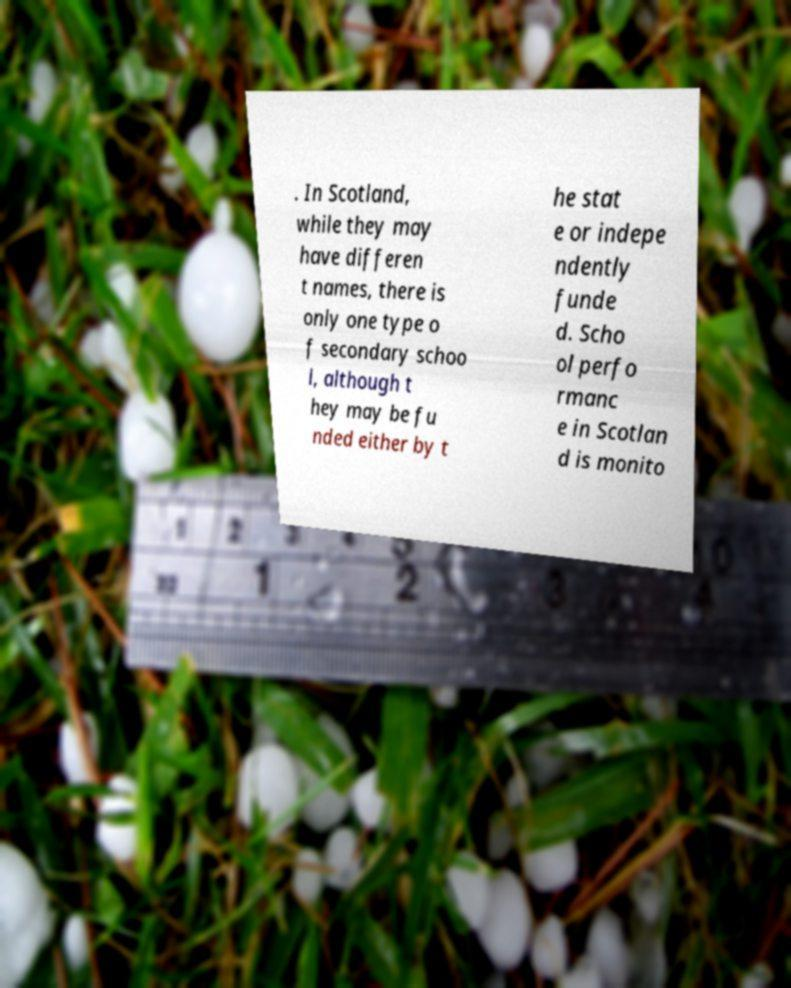Could you extract and type out the text from this image? . In Scotland, while they may have differen t names, there is only one type o f secondary schoo l, although t hey may be fu nded either by t he stat e or indepe ndently funde d. Scho ol perfo rmanc e in Scotlan d is monito 